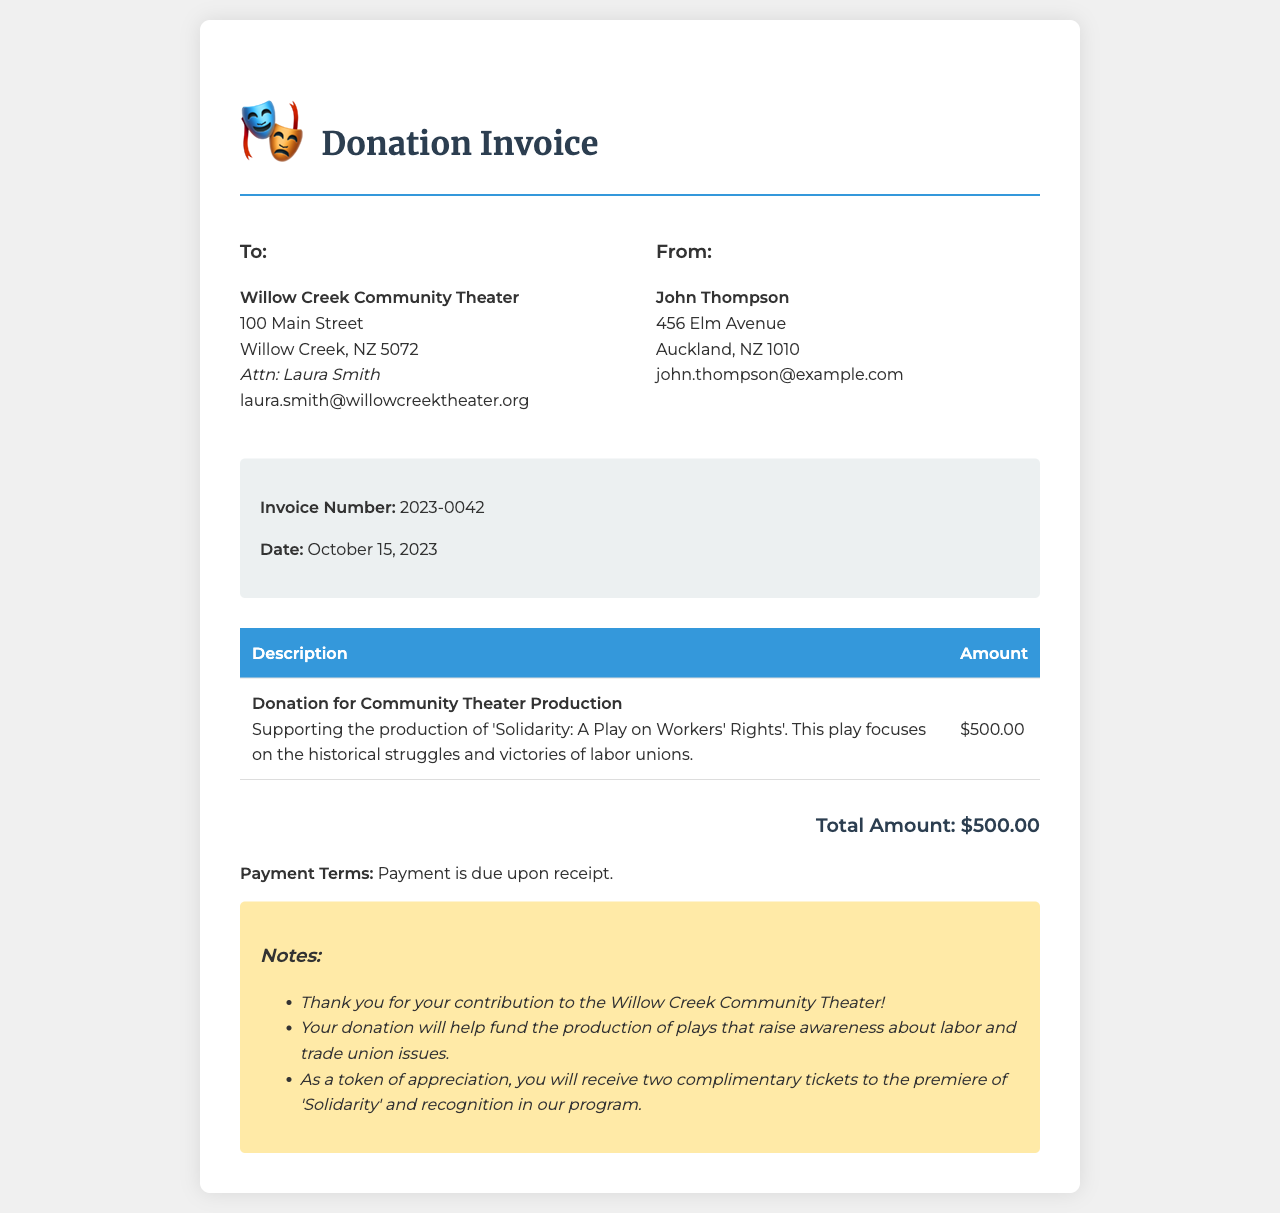What is the invoice number? The invoice number is specified as a unique identifier for the transaction, which is 2023-0042.
Answer: 2023-0042 Who is the invoice addressed to? The "To" section contains the name and address of the recipient, which is Willow Creek Community Theater.
Answer: Willow Creek Community Theater What is the total amount of the donation? The total amount is listed under the donation details, which amounts to $500.00.
Answer: $500.00 What is the date of the invoice? The date of the invoice is provided to indicate when it was issued, which is October 15, 2023.
Answer: October 15, 2023 What play does the donation support? The document specifies the title of the play that the donation supports, which is 'Solidarity: A Play on Workers' Rights'.
Answer: 'Solidarity: A Play on Workers' Rights' What is included as a benefit for the donor? The invoice mentions specific benefits for the donor, highlighting that they will receive two complimentary tickets to the premiere of 'Solidarity'.
Answer: Two complimentary tickets What is the payment term indicated in the invoice? The payment term outlines when payment is expected and is stated clearly, which is due upon receipt.
Answer: Due upon receipt Who is the contact person for the theater? The invoice lists a contact person for the theater in the "To" section, which is Laura Smith.
Answer: Laura Smith What type of organization is the invoice addressed to? The organization receiving the donation is categorized as a theater group, specifically a community theater.
Answer: Community theater 